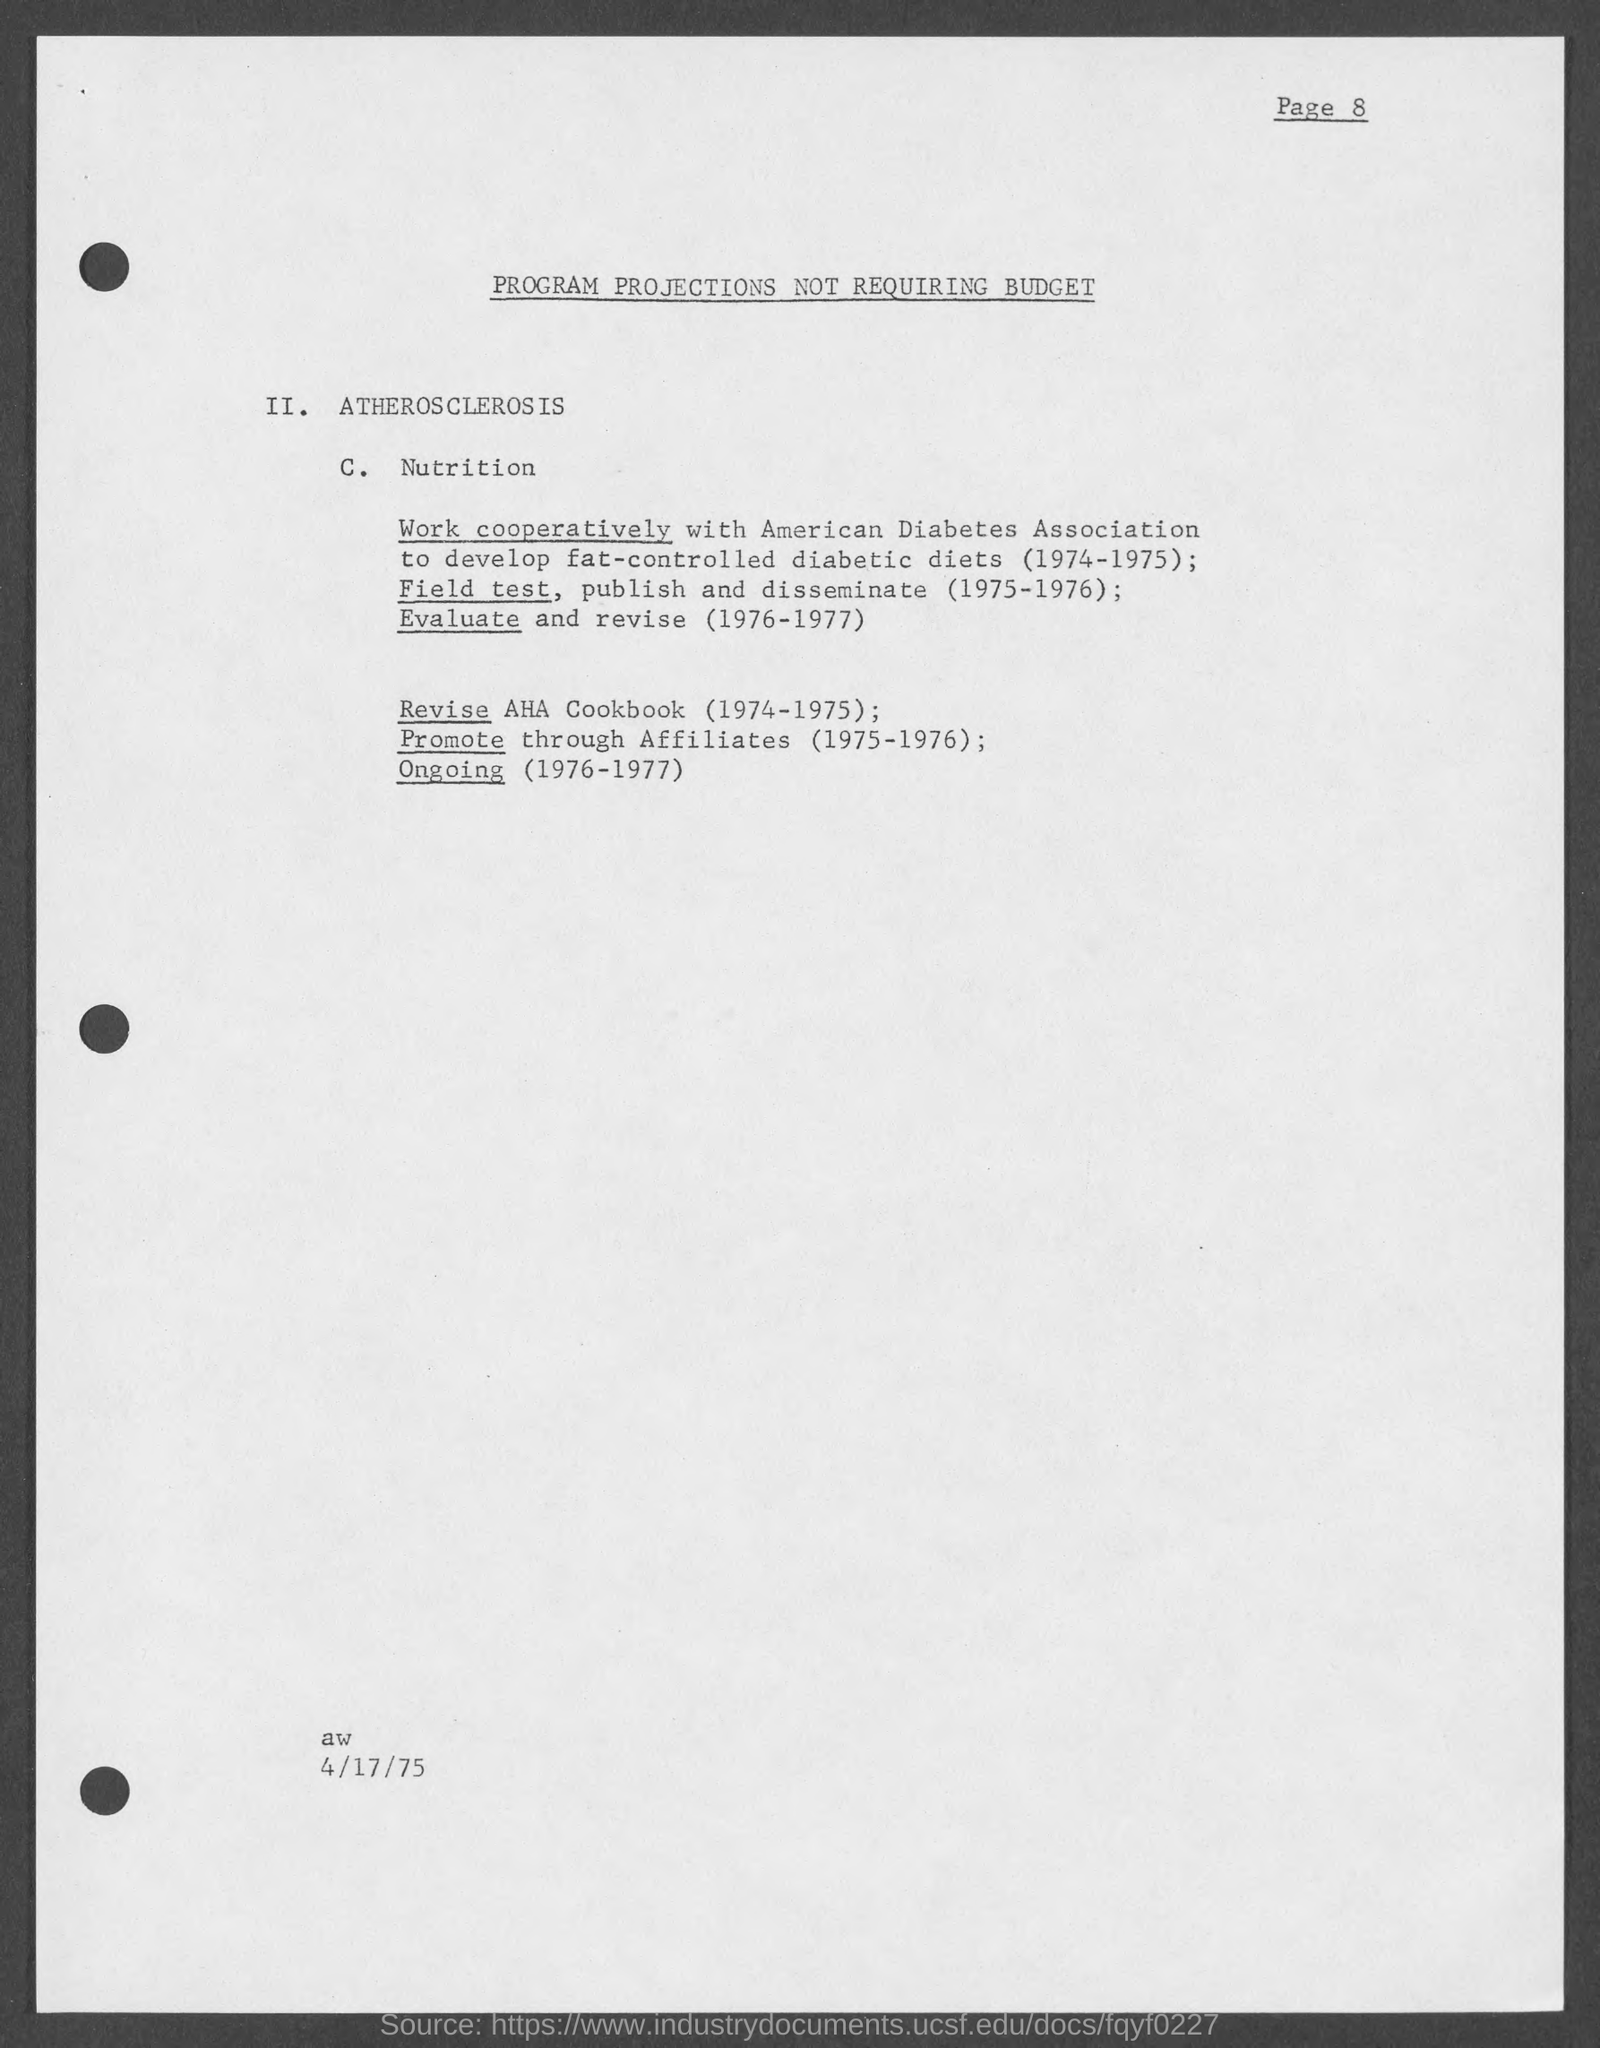Give some essential details in this illustration. The page number on this document is 8. The AHA Cookbook should be revised from 1974 to 1975. 